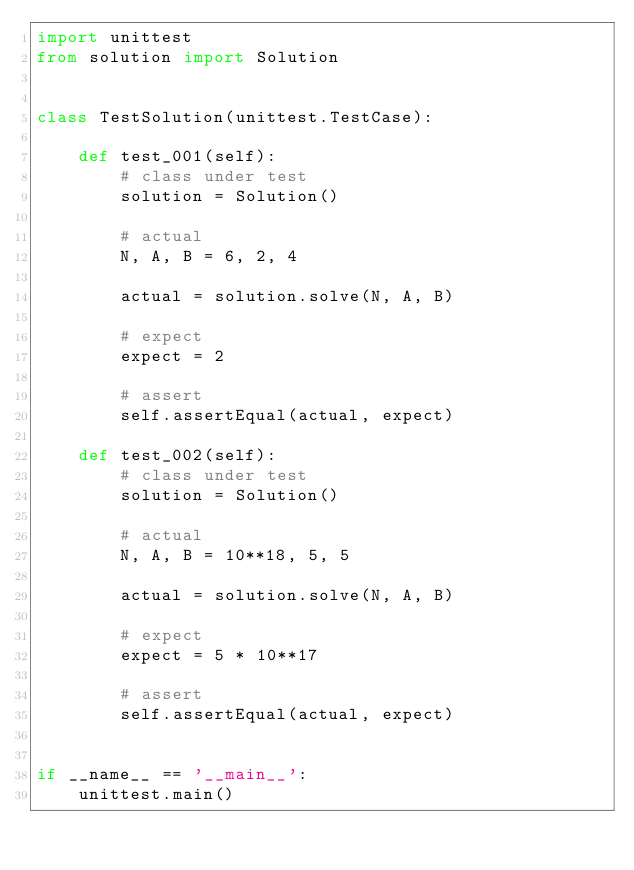Convert code to text. <code><loc_0><loc_0><loc_500><loc_500><_Python_>import unittest
from solution import Solution


class TestSolution(unittest.TestCase):

    def test_001(self):
        # class under test
        solution = Solution()

        # actual
        N, A, B = 6, 2, 4

        actual = solution.solve(N, A, B)

        # expect
        expect = 2

        # assert
        self.assertEqual(actual, expect)

    def test_002(self):
        # class under test
        solution = Solution()

        # actual
        N, A, B = 10**18, 5, 5

        actual = solution.solve(N, A, B)

        # expect
        expect = 5 * 10**17

        # assert
        self.assertEqual(actual, expect)


if __name__ == '__main__':
    unittest.main()
</code> 